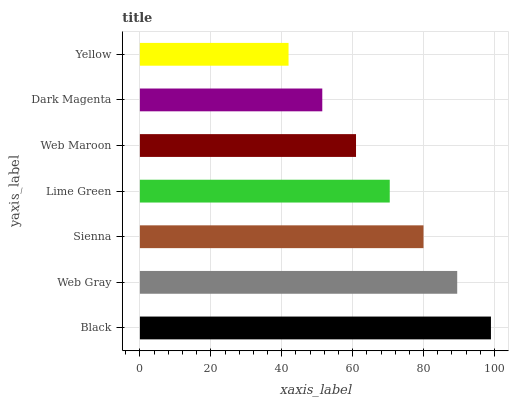Is Yellow the minimum?
Answer yes or no. Yes. Is Black the maximum?
Answer yes or no. Yes. Is Web Gray the minimum?
Answer yes or no. No. Is Web Gray the maximum?
Answer yes or no. No. Is Black greater than Web Gray?
Answer yes or no. Yes. Is Web Gray less than Black?
Answer yes or no. Yes. Is Web Gray greater than Black?
Answer yes or no. No. Is Black less than Web Gray?
Answer yes or no. No. Is Lime Green the high median?
Answer yes or no. Yes. Is Lime Green the low median?
Answer yes or no. Yes. Is Web Gray the high median?
Answer yes or no. No. Is Web Gray the low median?
Answer yes or no. No. 